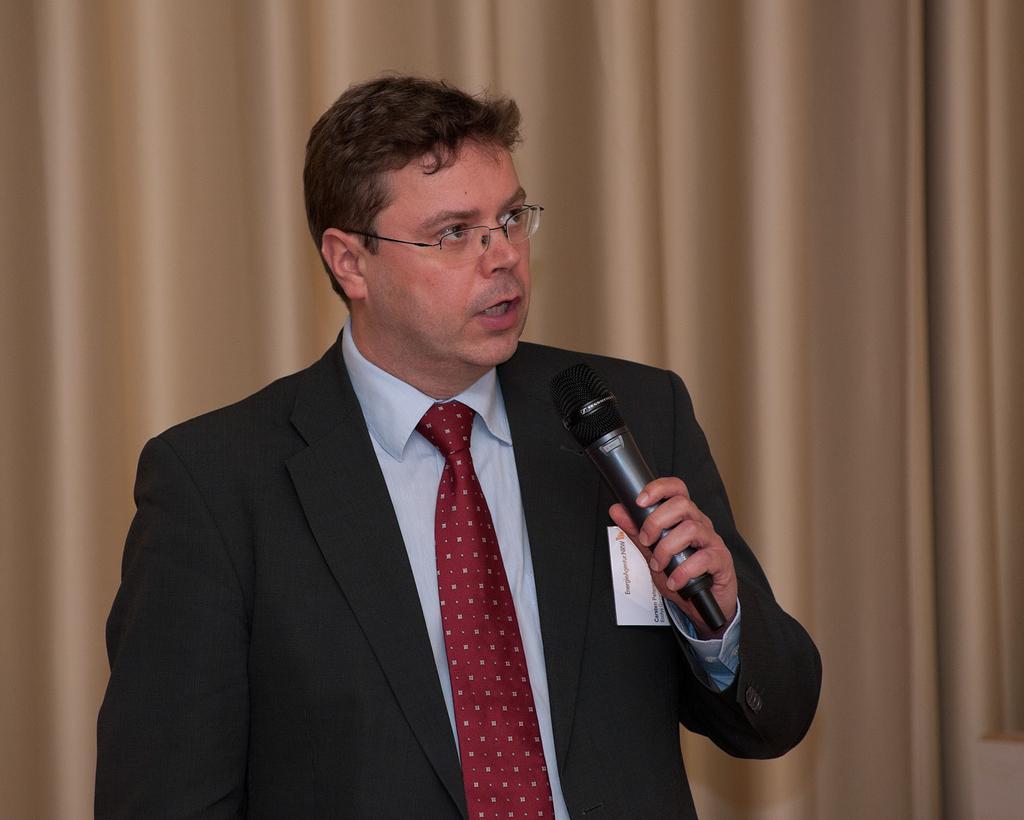Describe this image in one or two sentences. In this image i can see a man talking holding a microphone. At the background i can see a curtain. 